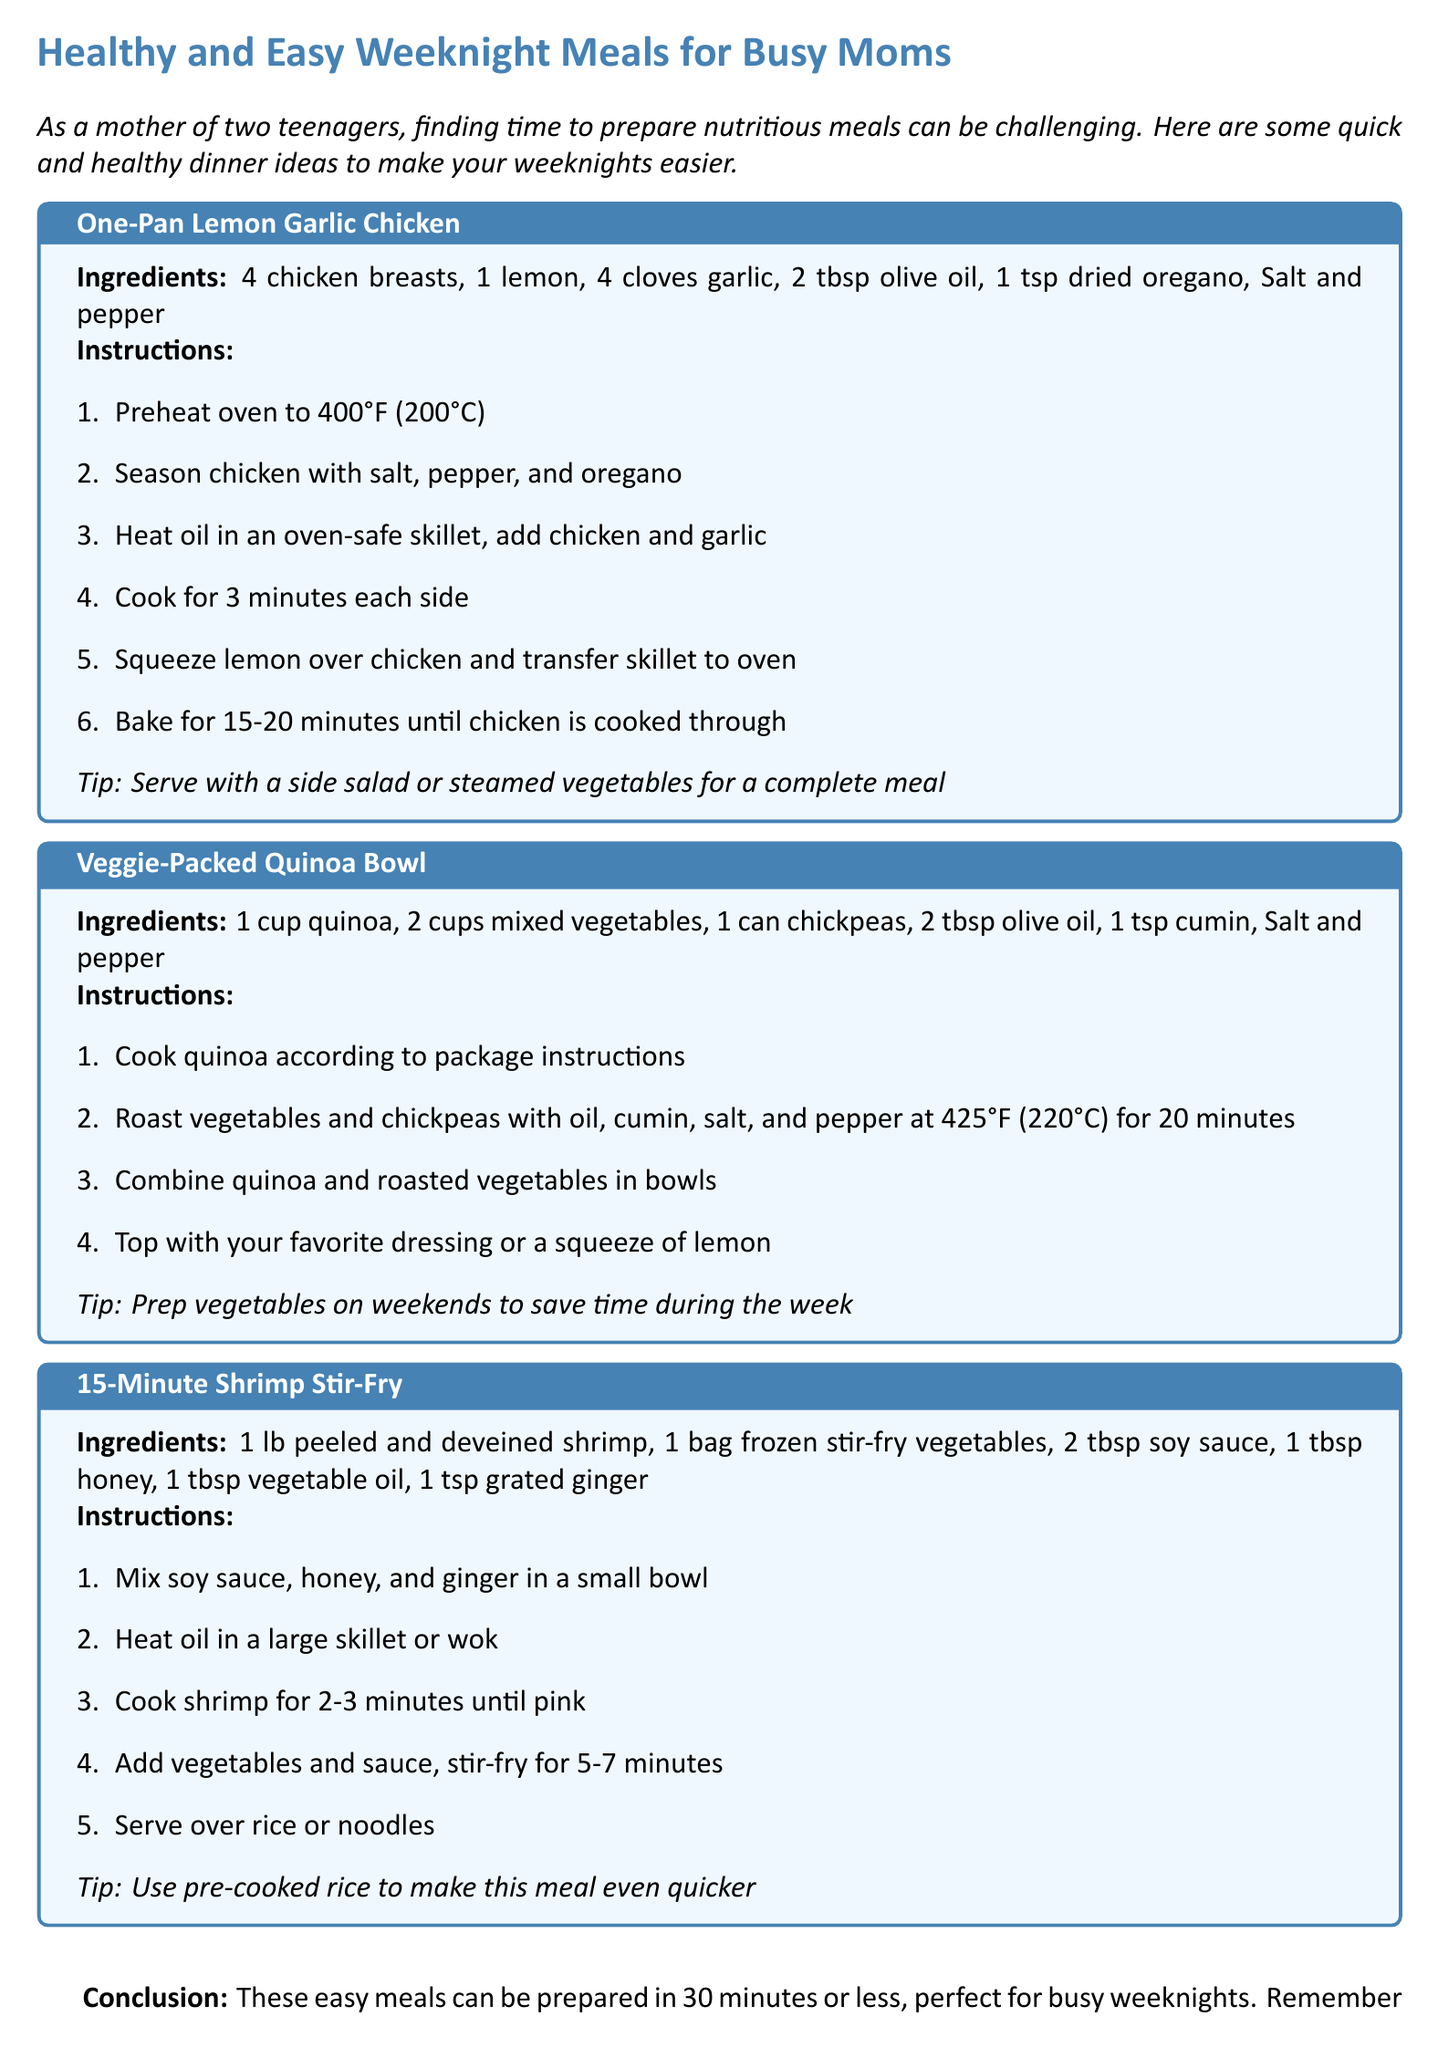What is the title of the document? The title of the document provides insight into the focus of the meal ideas Presented, which is aimed at busy mothers.
Answer: Healthy and Easy Weeknight Meals for Busy Moms How many chicken breasts are needed for the One-Pan Lemon Garlic Chicken? The document specifies the ingredients for each meal, stating the exact quantity required.
Answer: 4 chicken breasts At what temperature should the oven be preheated for the One-Pan Lemon Garlic Chicken? The cooking instructions indicate the temperature settings necessary for each recipe.
Answer: 400°F (200°C) What is the cooking time for the Veggie-Packed Quinoa Bowl's roasted vegetables? The instructions for each meal detail the duration required for specific cooking steps.
Answer: 20 minutes How long does it take to prepare the 15-Minute Shrimp Stir-Fry? The title and introduction suggest that meals can be prepared quickly, reinforcing the efficiency of these recipes.
Answer: 15 minutes What should be served with the One-Pan Lemon Garlic Chicken for a complete meal? The tips section provides recommendations for enhancing the meal experience.
Answer: Side salad or steamed vegetables What is the ingredient that adds flavor in the 15-Minute Shrimp Stir-Fry? The ingredients list for each recipe includes different flavor enhancers used in meal preparation.
Answer: Grated ginger What cooking technique is used for the Veggie-Packed Quinoa Bowl? The instructions give insights into the methods for preparing the meals, showcasing diverse cooking techniques.
Answer: Roast How many meals are provided in the document? The document outlines various meal ideas, summarizing the number of distinct recipes included.
Answer: 3 meals 